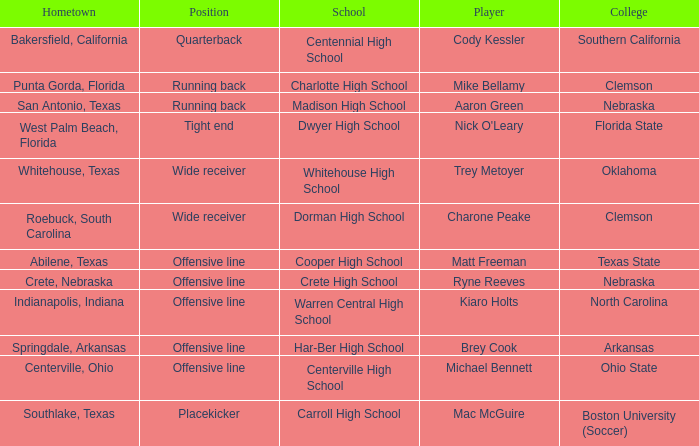What college did Matt Freeman go to? Texas State. 